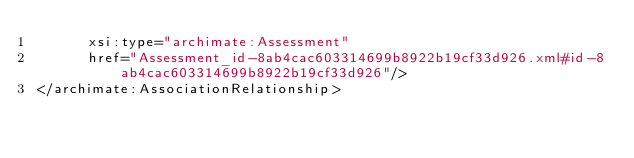<code> <loc_0><loc_0><loc_500><loc_500><_XML_>      xsi:type="archimate:Assessment"
      href="Assessment_id-8ab4cac603314699b8922b19cf33d926.xml#id-8ab4cac603314699b8922b19cf33d926"/>
</archimate:AssociationRelationship>
</code> 